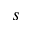<formula> <loc_0><loc_0><loc_500><loc_500>s</formula> 